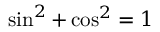Convert formula to latex. <formula><loc_0><loc_0><loc_500><loc_500>\sin ^ { 2 } + \cos ^ { 2 } = 1</formula> 